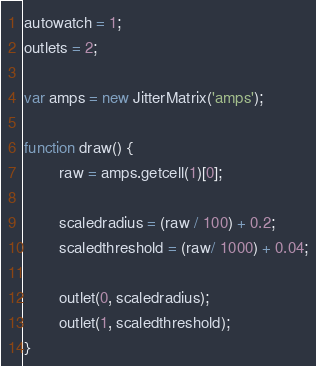<code> <loc_0><loc_0><loc_500><loc_500><_JavaScript_>autowatch = 1;
outlets = 2;

var amps = new JitterMatrix('amps');

function draw() {
		raw = amps.getcell(1)[0];

		scaledradius = (raw / 100) + 0.2;
		scaledthreshold = (raw/ 1000) + 0.04;

		outlet(0, scaledradius);
		outlet(1, scaledthreshold);
}
</code> 